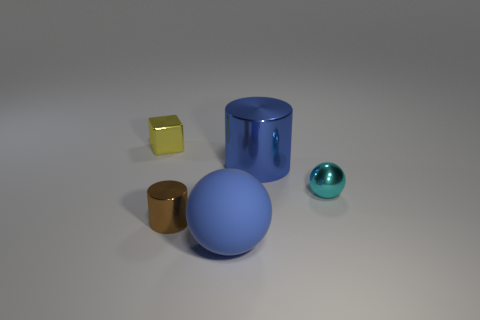Add 1 yellow metallic things. How many objects exist? 6 Subtract all spheres. How many objects are left? 3 Subtract 0 purple spheres. How many objects are left? 5 Subtract all metal things. Subtract all tiny brown metallic objects. How many objects are left? 0 Add 3 large matte balls. How many large matte balls are left? 4 Add 5 cyan things. How many cyan things exist? 6 